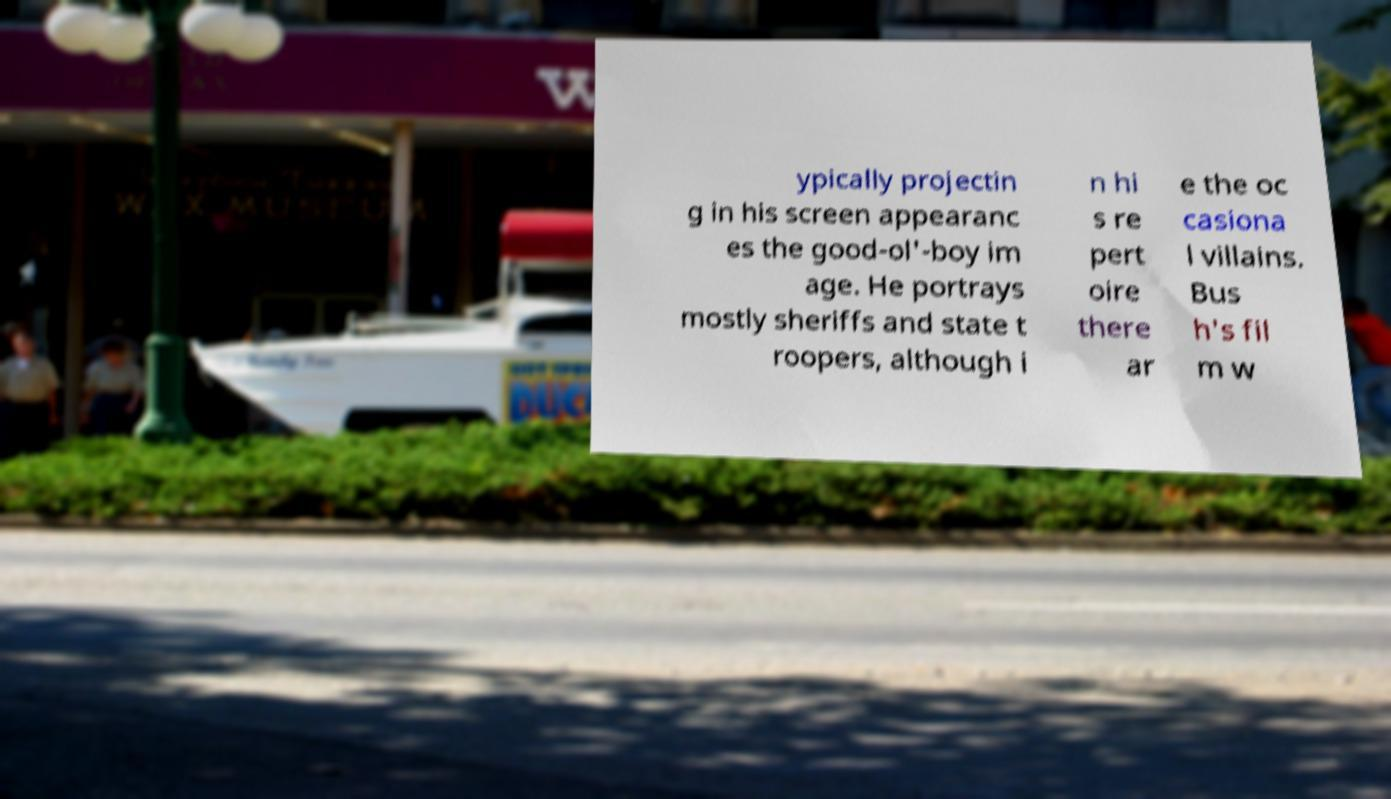What messages or text are displayed in this image? I need them in a readable, typed format. ypically projectin g in his screen appearanc es the good-ol'-boy im age. He portrays mostly sheriffs and state t roopers, although i n hi s re pert oire there ar e the oc casiona l villains. Bus h's fil m w 